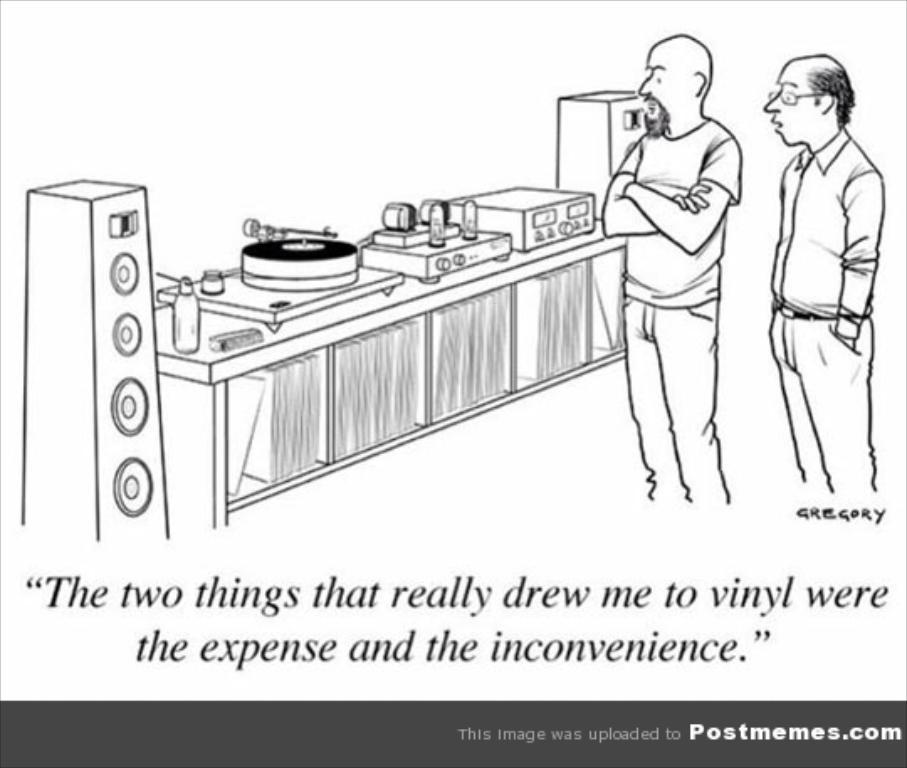What is the main subject of the image? The main subject of the image is a sketch. What else can be seen at the bottom of the image? There is text at the bottom of the image. What type of milk is being used in the sketch? There is no milk present in the image, as it features a sketch and text. What type of apparel is being worn by the subject in the sketch? There is no subject wearing apparel in the sketch, as it is not a detailed illustration. 